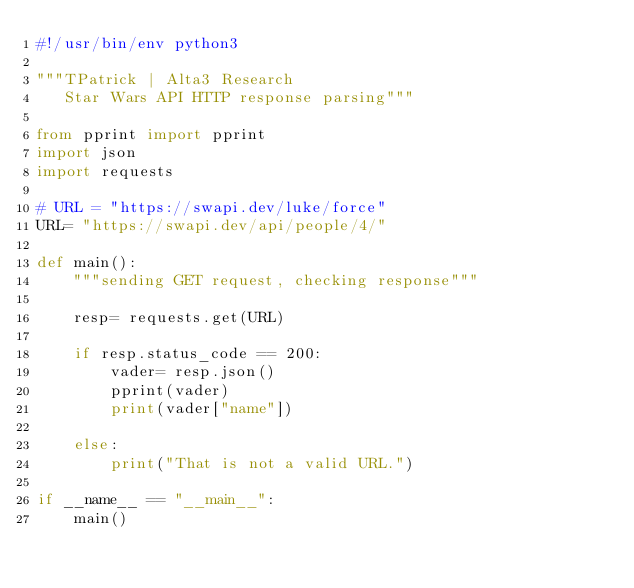<code> <loc_0><loc_0><loc_500><loc_500><_Python_>#!/usr/bin/env python3

"""TPatrick | Alta3 Research
   Star Wars API HTTP response parsing"""

from pprint import pprint
import json
import requests

# URL = "https://swapi.dev/luke/force"
URL= "https://swapi.dev/api/people/4/"

def main():
    """sending GET request, checking response"""

    resp= requests.get(URL)

    if resp.status_code == 200:
        vader= resp.json()
        pprint(vader)
        print(vader["name"])

    else:
        print("That is not a valid URL.")

if __name__ == "__main__":
    main()
</code> 